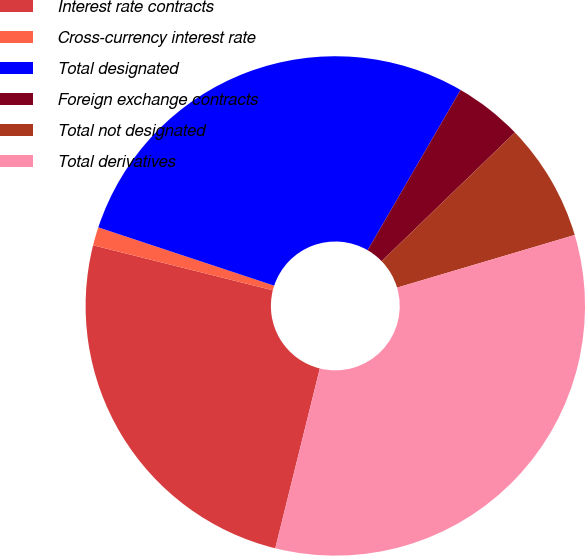Convert chart. <chart><loc_0><loc_0><loc_500><loc_500><pie_chart><fcel>Interest rate contracts<fcel>Cross-currency interest rate<fcel>Total designated<fcel>Foreign exchange contracts<fcel>Total not designated<fcel>Total derivatives<nl><fcel>25.04%<fcel>1.19%<fcel>28.27%<fcel>4.41%<fcel>7.64%<fcel>33.45%<nl></chart> 